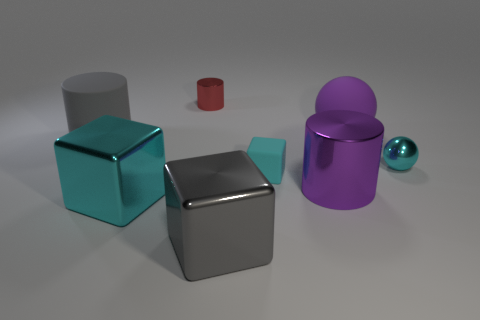Are there the same number of cyan cubes behind the small red cylinder and big metal objects to the right of the matte block?
Offer a very short reply. No. How many small metal spheres are the same color as the large matte cylinder?
Your answer should be very brief. 0. There is a small block that is the same color as the small shiny sphere; what is its material?
Your answer should be compact. Rubber. How many shiny objects are either big gray cubes or cylinders?
Your response must be concise. 3. There is a small thing behind the gray cylinder; is it the same shape as the tiny shiny object to the right of the cyan matte block?
Keep it short and to the point. No. How many red cylinders are in front of the gray rubber cylinder?
Keep it short and to the point. 0. Are there any tiny red cylinders that have the same material as the big purple cylinder?
Your answer should be very brief. Yes. There is a block that is the same size as the gray shiny object; what is its material?
Offer a very short reply. Metal. Is the material of the small cube the same as the large gray block?
Provide a succinct answer. No. How many things are either large gray matte things or tiny metal balls?
Your response must be concise. 2. 